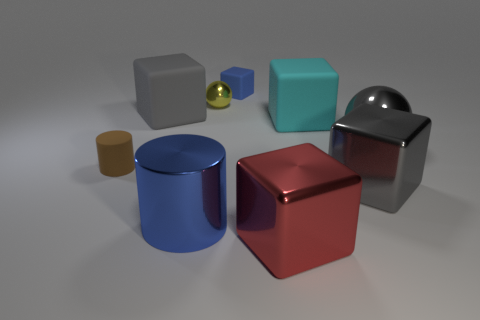Subtract all red blocks. How many blocks are left? 4 Subtract all blue cubes. How many cubes are left? 4 Subtract all brown cubes. Subtract all brown balls. How many cubes are left? 5 Add 1 cyan rubber cubes. How many objects exist? 10 Subtract all cylinders. How many objects are left? 7 Add 4 matte blocks. How many matte blocks exist? 7 Subtract 0 cyan cylinders. How many objects are left? 9 Subtract all tiny blue rubber cubes. Subtract all small spheres. How many objects are left? 7 Add 1 brown matte cylinders. How many brown matte cylinders are left? 2 